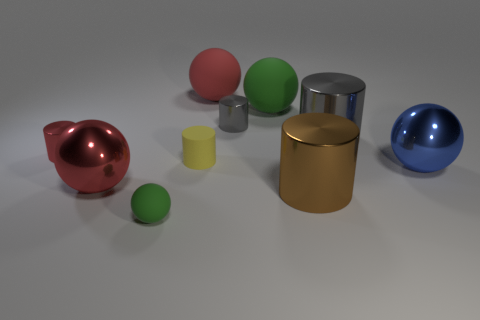Is there a tiny yellow thing that has the same shape as the large red matte thing?
Make the answer very short. No. There is a gray metal object that is in front of the gray metallic thing that is on the left side of the brown object; is there a blue metal thing behind it?
Offer a very short reply. No. Is the number of tiny red cylinders behind the small green ball greater than the number of red rubber objects to the right of the large brown shiny object?
Your answer should be compact. Yes. What is the material of the green thing that is the same size as the yellow rubber object?
Provide a succinct answer. Rubber. How many big things are cylinders or brown objects?
Your answer should be compact. 2. Do the big gray object and the small red thing have the same shape?
Provide a succinct answer. Yes. How many metallic cylinders are both left of the big brown thing and to the right of the matte cylinder?
Provide a short and direct response. 1. Is there anything else that has the same color as the small matte ball?
Keep it short and to the point. Yes. What is the shape of the red thing that is the same material as the small green sphere?
Make the answer very short. Sphere. Do the brown shiny cylinder and the yellow matte object have the same size?
Provide a succinct answer. No. 